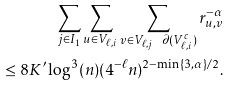Convert formula to latex. <formula><loc_0><loc_0><loc_500><loc_500>\sum _ { j \in I _ { 1 } } \sum _ { u \in V _ { \ell , i } } \sum _ { v \in V _ { \ell , j } \ \partial ( V _ { \ell , i } ^ { c } ) } r _ { u , v } ^ { - \alpha } \\ \leq 8 K ^ { \prime } \log ^ { 3 } ( n ) ( 4 ^ { - \ell } n ) ^ { 2 - \min \{ 3 , \alpha \} / 2 } .</formula> 